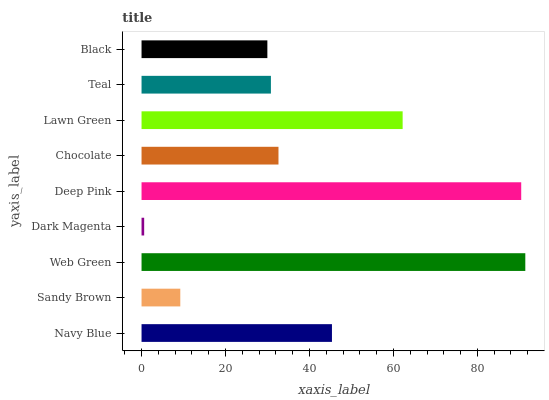Is Dark Magenta the minimum?
Answer yes or no. Yes. Is Web Green the maximum?
Answer yes or no. Yes. Is Sandy Brown the minimum?
Answer yes or no. No. Is Sandy Brown the maximum?
Answer yes or no. No. Is Navy Blue greater than Sandy Brown?
Answer yes or no. Yes. Is Sandy Brown less than Navy Blue?
Answer yes or no. Yes. Is Sandy Brown greater than Navy Blue?
Answer yes or no. No. Is Navy Blue less than Sandy Brown?
Answer yes or no. No. Is Chocolate the high median?
Answer yes or no. Yes. Is Chocolate the low median?
Answer yes or no. Yes. Is Dark Magenta the high median?
Answer yes or no. No. Is Sandy Brown the low median?
Answer yes or no. No. 